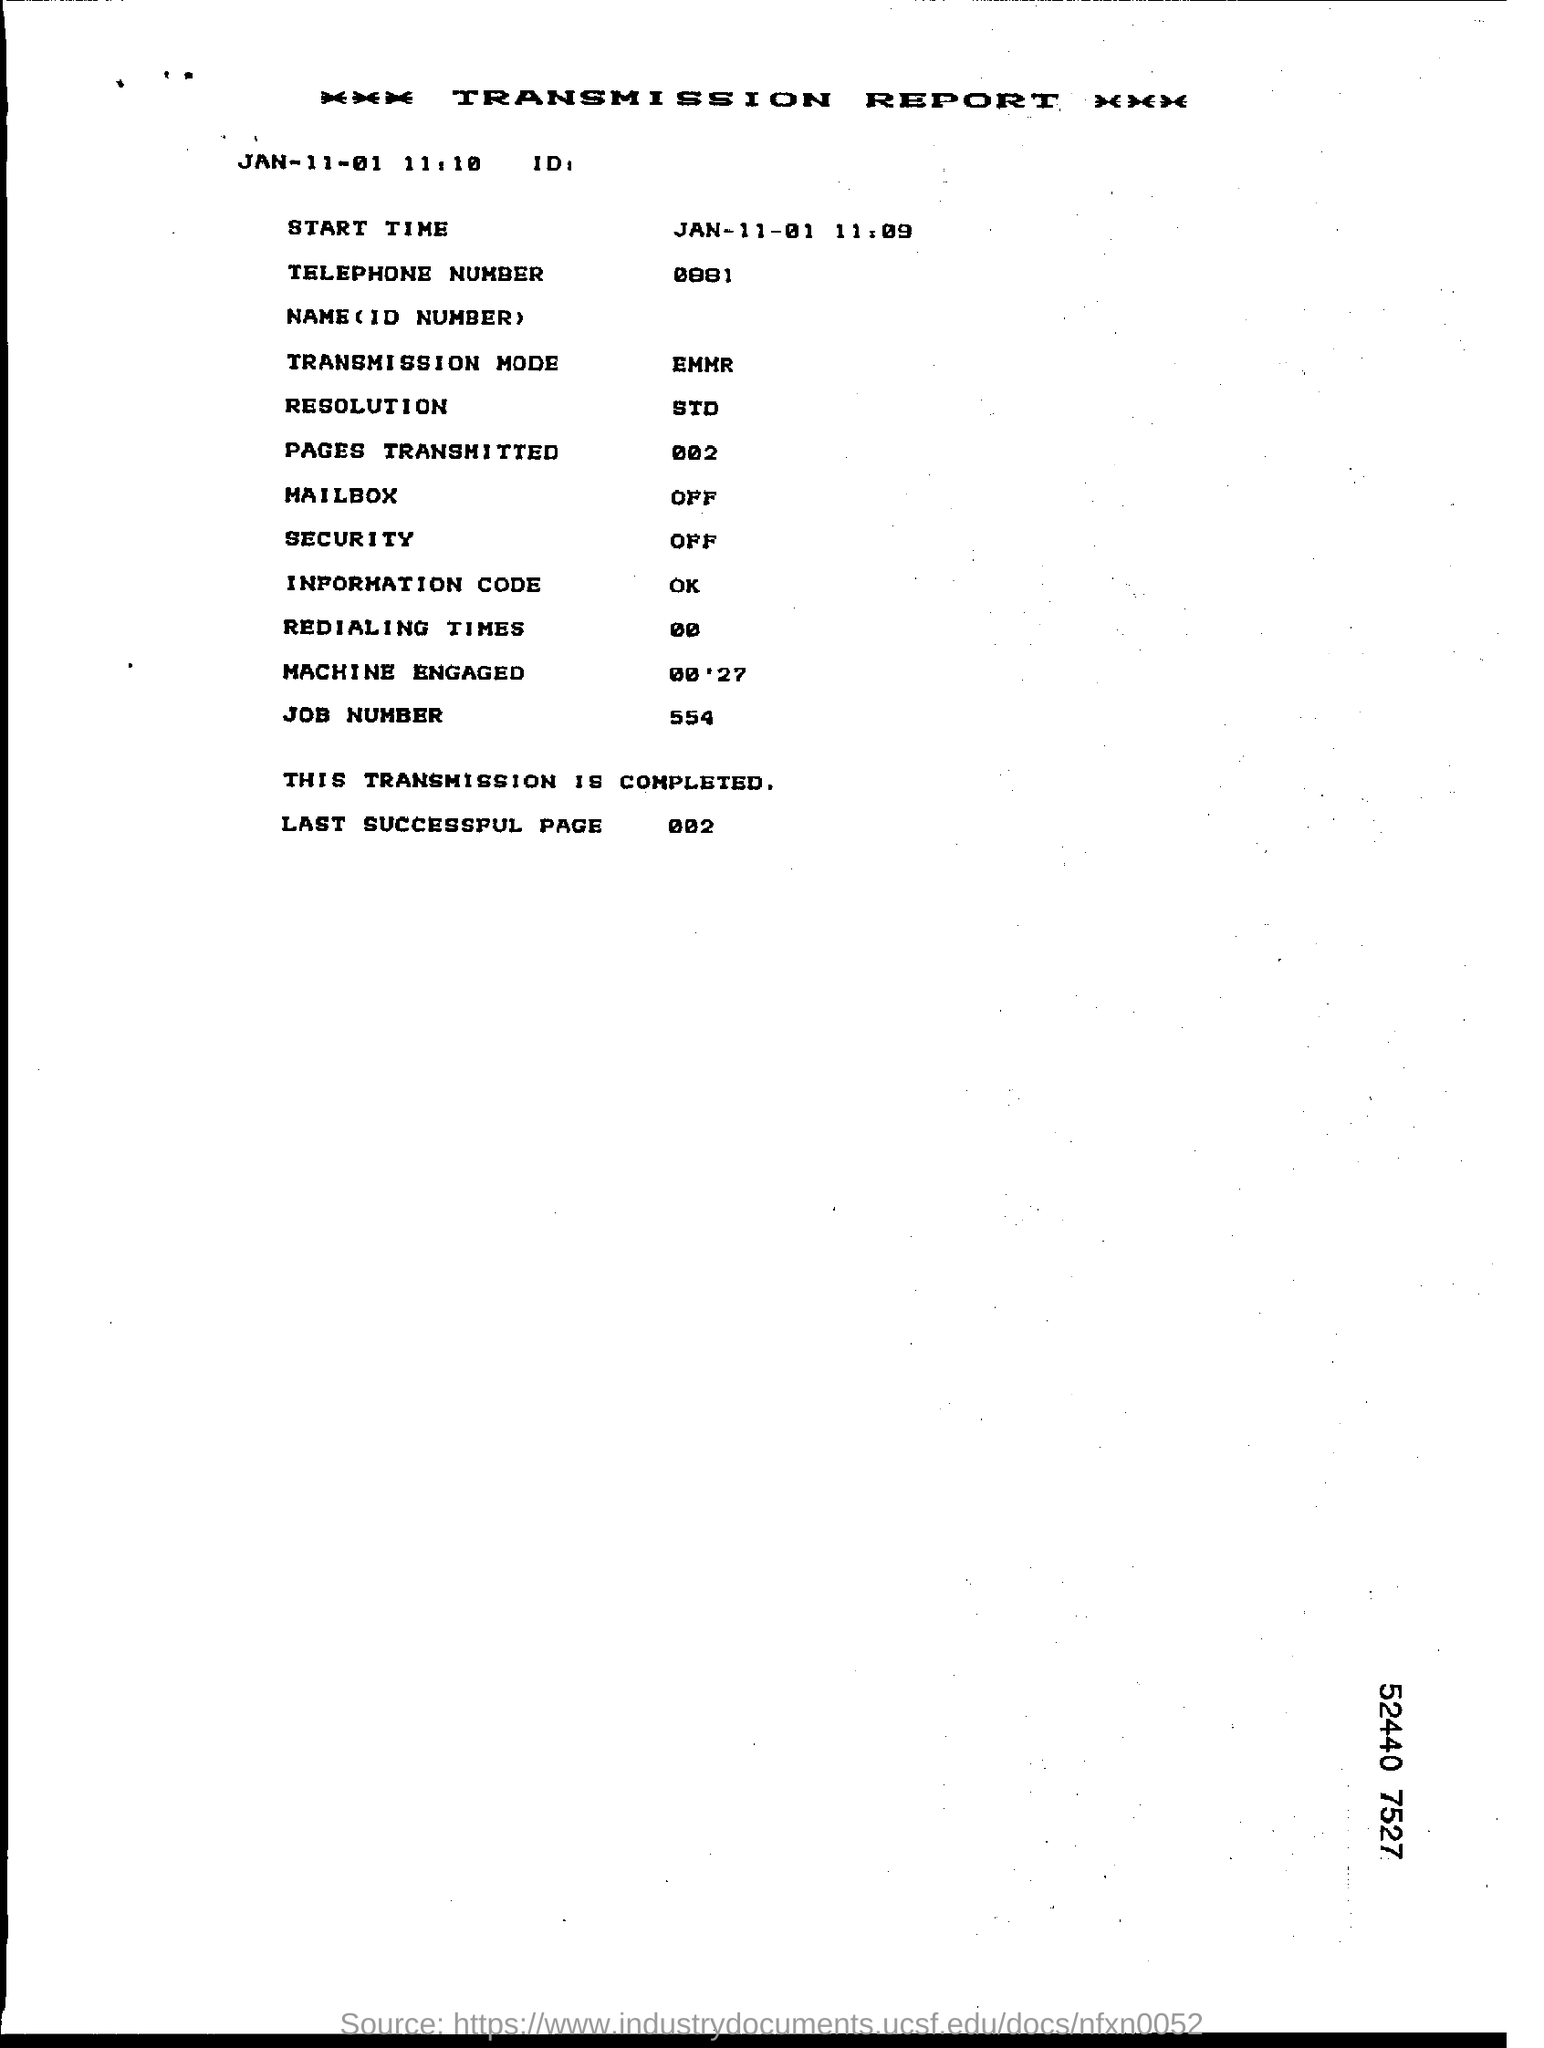What is the telephone number given in the transmission report ?
Offer a terse response. 0881. What is the status of transmission mode in the transmission report ?
Keep it short and to the point. EMMR. What is the job number given in the transmission report ?
Offer a very short reply. 554. What is the number of last successful page in the report ?
Give a very brief answer. 002. What is the status of the mailbox in the transmission report ?
Your answer should be compact. OFF. How many pages are transmitted in the report ?
Provide a short and direct response. 002. What is the information code given in the report ?
Provide a succinct answer. Ok. What is the machine engaged time given in the transmission report ?
Offer a very short reply. 00'27. 